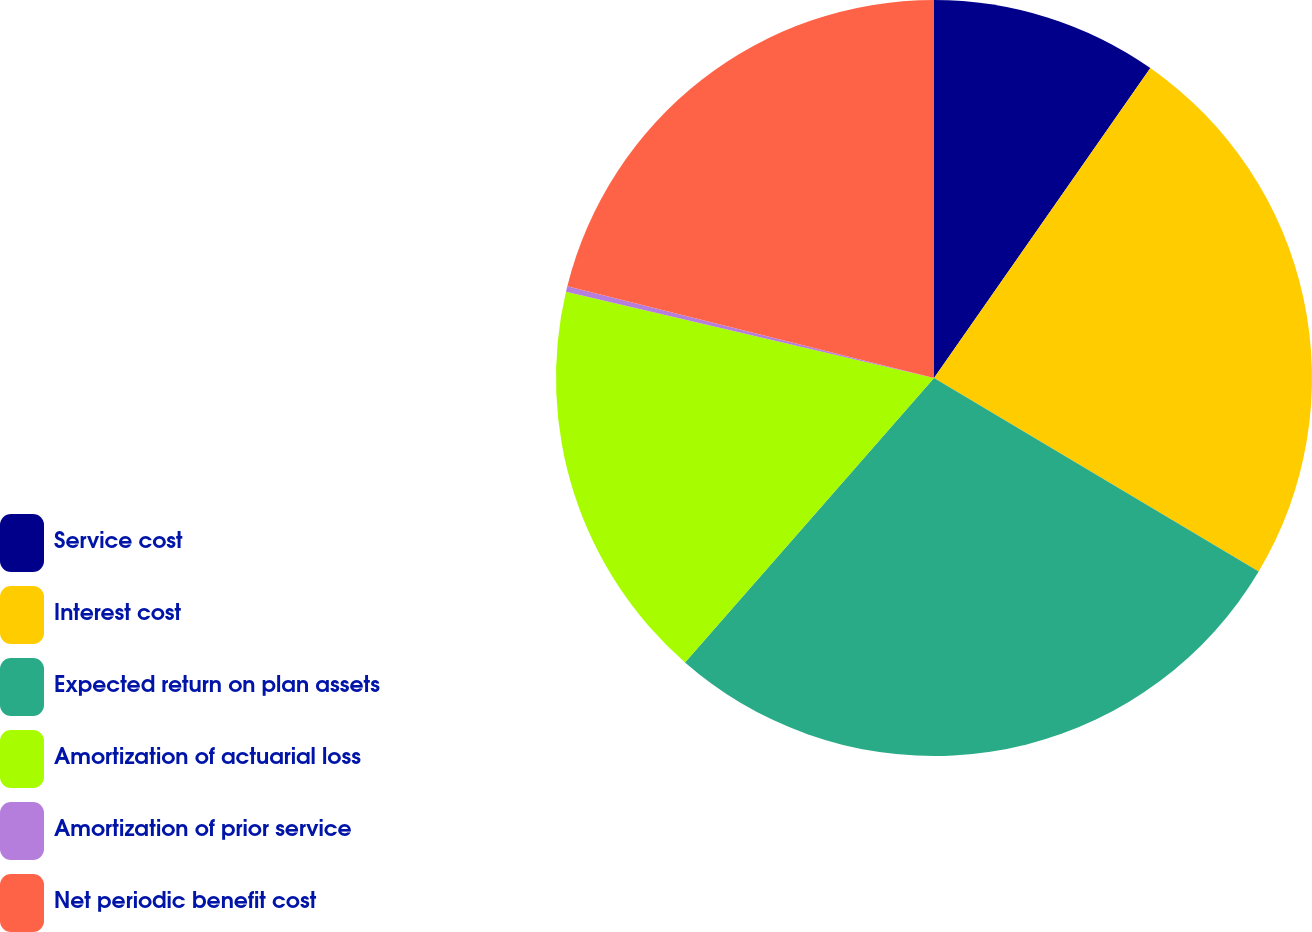Convert chart. <chart><loc_0><loc_0><loc_500><loc_500><pie_chart><fcel>Service cost<fcel>Interest cost<fcel>Expected return on plan assets<fcel>Amortization of actuarial loss<fcel>Amortization of prior service<fcel>Net periodic benefit cost<nl><fcel>9.7%<fcel>23.86%<fcel>27.89%<fcel>17.22%<fcel>0.24%<fcel>21.1%<nl></chart> 